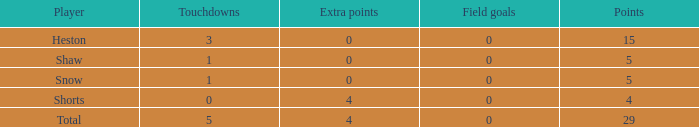If a player had 5 touchdowns and more than 0 extra points, what was the total number of field goals they had? 1.0. 